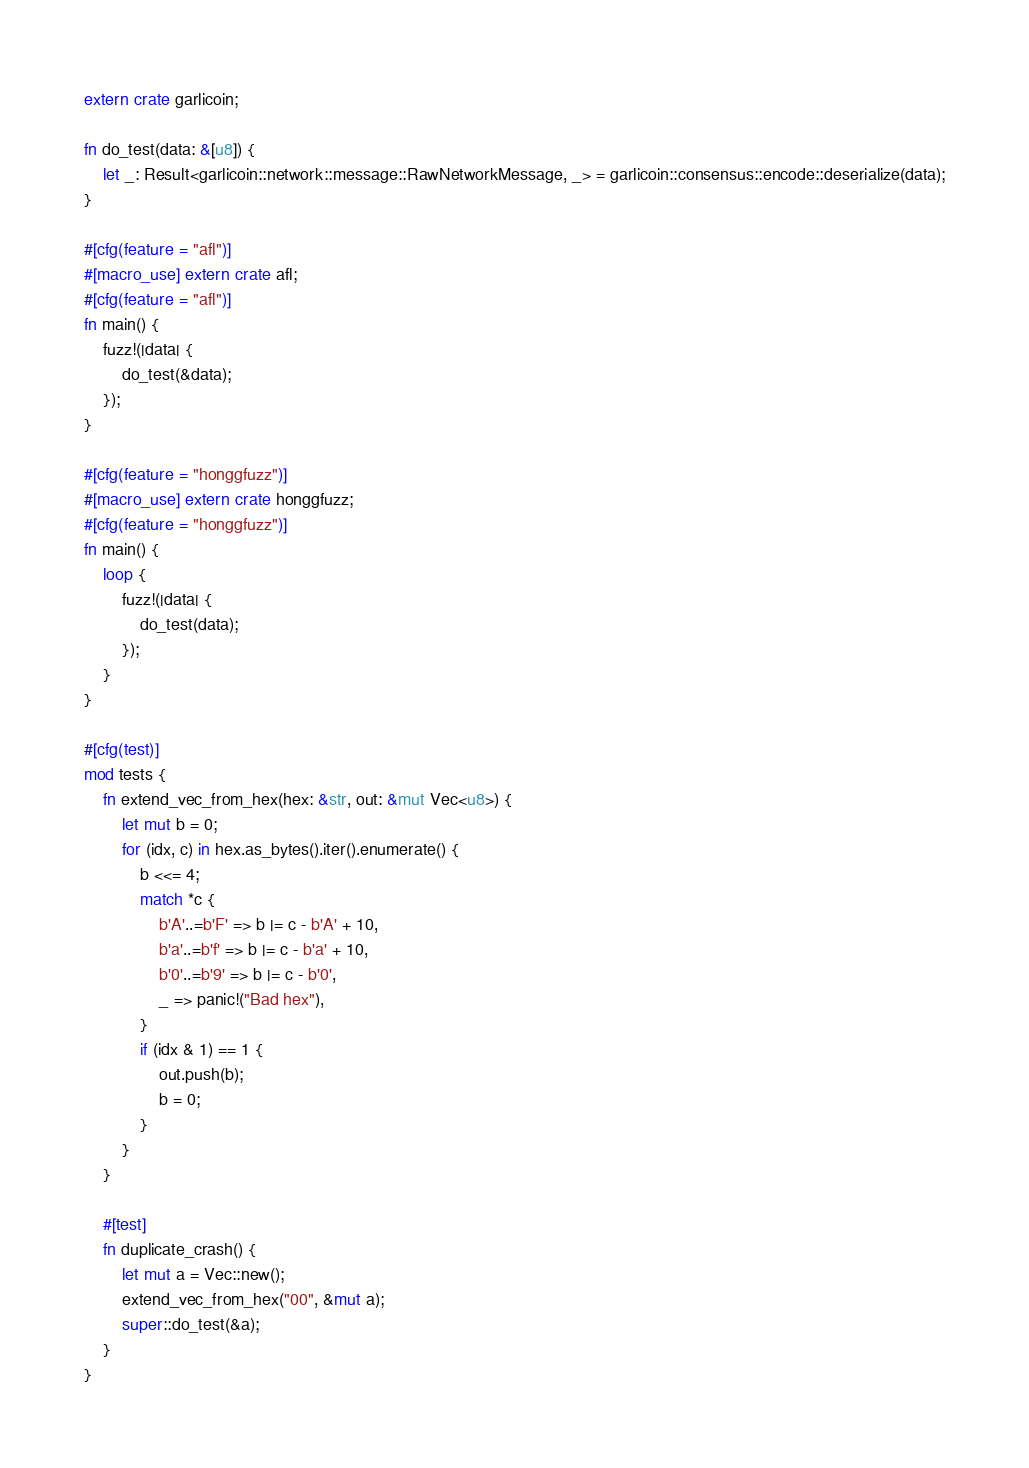<code> <loc_0><loc_0><loc_500><loc_500><_Rust_>extern crate garlicoin;

fn do_test(data: &[u8]) {
    let _: Result<garlicoin::network::message::RawNetworkMessage, _> = garlicoin::consensus::encode::deserialize(data);
}

#[cfg(feature = "afl")]
#[macro_use] extern crate afl;
#[cfg(feature = "afl")]
fn main() {
    fuzz!(|data| {
        do_test(&data);
    });
}

#[cfg(feature = "honggfuzz")]
#[macro_use] extern crate honggfuzz;
#[cfg(feature = "honggfuzz")]
fn main() {
    loop {
        fuzz!(|data| {
            do_test(data);
        });
    }
}

#[cfg(test)]
mod tests {
    fn extend_vec_from_hex(hex: &str, out: &mut Vec<u8>) {
        let mut b = 0;
        for (idx, c) in hex.as_bytes().iter().enumerate() {
            b <<= 4;
            match *c {
                b'A'..=b'F' => b |= c - b'A' + 10,
                b'a'..=b'f' => b |= c - b'a' + 10,
                b'0'..=b'9' => b |= c - b'0',
                _ => panic!("Bad hex"),
            }
            if (idx & 1) == 1 {
                out.push(b);
                b = 0;
            }
        }
    }

    #[test]
    fn duplicate_crash() {
        let mut a = Vec::new();
        extend_vec_from_hex("00", &mut a);
        super::do_test(&a);
    }
}
</code> 